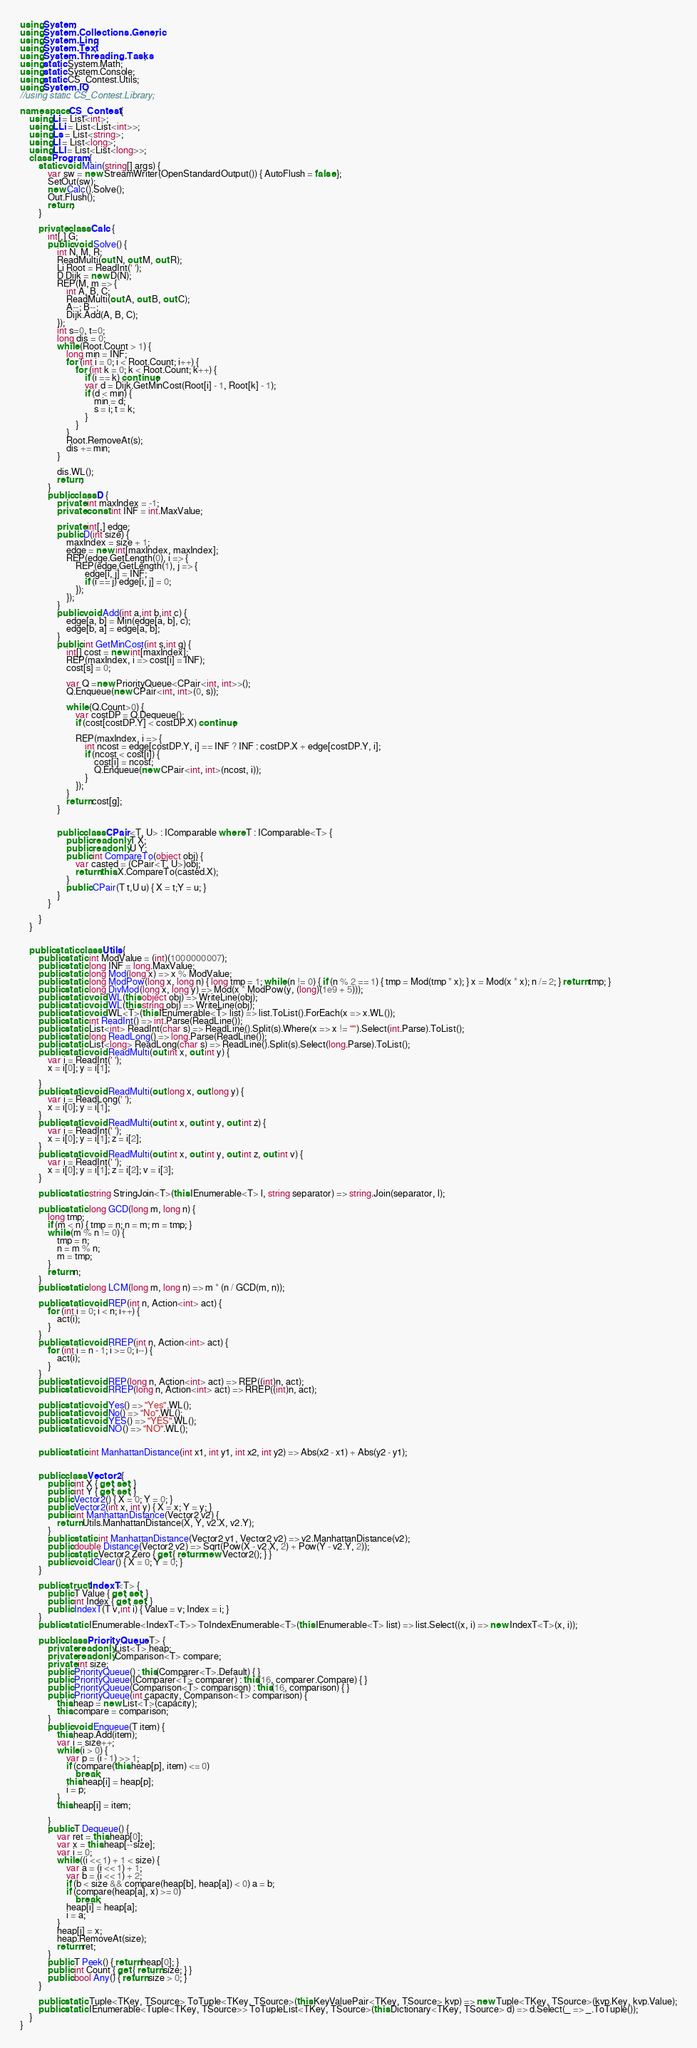Convert code to text. <code><loc_0><loc_0><loc_500><loc_500><_C#_>using System;
using System.Collections.Generic;
using System.Linq;
using System.Text;
using System.Threading.Tasks;
using static System.Math;
using static System.Console;
using static CS_Contest.Utils;
using System.IO;
//using static CS_Contest.Library;

namespace CS_Contest {
	using Li = List<int>;
	using LLi = List<List<int>>;
	using Ls = List<string>;
	using Ll = List<long>;
	using LLl = List<List<long>>;
	class Program {
		static void Main(string[] args) {
			var sw = new StreamWriter(OpenStandardOutput()) { AutoFlush = false };
			SetOut(sw);
			new Calc().Solve();
			Out.Flush();
			return;
        }

		private class Calc {
			int[,] G;
			public void Solve() {
				int N, M, R;
				ReadMulti(out N, out M, out R);
				Li Root = ReadInt(' ');
				D Dijk = new D(N);
				REP(M, m => {
					int A, B, C;
					ReadMulti(out A, out B, out C);
					A--; B--;
					Dijk.Add(A, B, C);
				});
				int s=0, t=0;
				long dis = 0;
				while (Root.Count > 1) {
					long min = INF;
					for (int i = 0; i < Root.Count; i++) {
						for (int k = 0; k < Root.Count; k++) {
							if (i == k) continue;
							var d = Dijk.GetMinCost(Root[i] - 1, Root[k] - 1);
							if (d < min) {
								min = d;
								s = i; t = k;
							}
						}
					}
					Root.RemoveAt(s);
					dis += min;
				}
				
				dis.WL();
				return;
			}
			public class D {
				private int maxIndex = -1;
				private const int INF = int.MaxValue;

				private int[,] edge;
				public D(int size) {
					maxIndex = size + 1;
					edge = new int[maxIndex, maxIndex];
					REP(edge.GetLength(0), i => {
						REP(edge.GetLength(1), j => {
							edge[i, j] = INF;
							if (i == j) edge[i, j] = 0;
						});
					});
				}
				public void Add(int a,int b,int c) {
					edge[a, b] = Min(edge[a, b], c);
					edge[b, a] = edge[a, b];
				}
				public int GetMinCost(int s,int g) {
					int[] cost = new int[maxIndex];
					REP(maxIndex, i => cost[i] = INF);
					cost[s] = 0;

					var Q =new PriorityQueue<CPair<int, int>>();
					Q.Enqueue(new CPair<int, int>(0, s));

					while (Q.Count>0) {
						var costDP = Q.Dequeue();
						if (cost[costDP.Y] < costDP.X) continue;

						REP(maxIndex, i => {
							int ncost = edge[costDP.Y, i] == INF ? INF : costDP.X + edge[costDP.Y, i];
							if (ncost < cost[i]) {
								cost[i] = ncost;
								Q.Enqueue(new CPair<int, int>(ncost, i));
							}
						});
					}
					return cost[g];
				}


				public class CPair<T, U> : IComparable where T : IComparable<T> {
					public readonly T X;
					public readonly U Y;
					public int CompareTo(object obj) {
						var casted = (CPair<T, U>)obj;
						return this.X.CompareTo(casted.X);
					}
					public CPair(T t,U u) { X = t;Y = u; }
				}
			}
			
		}
	}


	public static class Utils {
		public static int ModValue = (int)(1000000007);
		public static long INF = long.MaxValue;
		public static long Mod(long x) => x % ModValue;
		public static long ModPow(long x, long n) { long tmp = 1; while (n != 0) { if (n % 2 == 1) { tmp = Mod(tmp * x); } x = Mod(x * x); n /= 2; } return tmp; }
		public static long DivMod(long x, long y) => Mod(x * ModPow(y, (long)(1e9 + 5)));
		public static void WL(this object obj) => WriteLine(obj);
		public static void WL(this string obj) => WriteLine(obj);
		public static void WL<T>(this IEnumerable<T> list) => list.ToList().ForEach(x => x.WL());
		public static int ReadInt() => int.Parse(ReadLine());
		public static List<int> ReadInt(char s) => ReadLine().Split(s).Where(x => x != "").Select(int.Parse).ToList();
		public static long ReadLong() => long.Parse(ReadLine());
		public static List<long> ReadLong(char s) => ReadLine().Split(s).Select(long.Parse).ToList();
		public static void ReadMulti(out int x, out int y) {
			var i = ReadInt(' ');
			x = i[0]; y = i[1];

		}
		public static void ReadMulti(out long x, out long y) {
			var i = ReadLong(' ');
			x = i[0]; y = i[1];
		}
		public static void ReadMulti(out int x, out int y, out int z) {
			var i = ReadInt(' ');
			x = i[0]; y = i[1]; z = i[2];
		}
		public static void ReadMulti(out int x, out int y, out int z, out int v) {
			var i = ReadInt(' ');
			x = i[0]; y = i[1]; z = i[2]; v = i[3];
		}

		public static string StringJoin<T>(this IEnumerable<T> l, string separator) => string.Join(separator, l);

		public static long GCD(long m, long n) {
			long tmp;
			if (m < n) { tmp = n; n = m; m = tmp; }
			while (m % n != 0) {
				tmp = n;
				n = m % n;
				m = tmp;
			}
			return n;
		}
		public static long LCM(long m, long n) => m * (n / GCD(m, n));

		public static void REP(int n, Action<int> act) {
			for (int i = 0; i < n; i++) {
				act(i);
			}
		}
		public static void RREP(int n, Action<int> act) {
			for (int i = n - 1; i >= 0; i--) {
				act(i);
			}
		}
		public static void REP(long n, Action<int> act) => REP((int)n, act);
		public static void RREP(long n, Action<int> act) => RREP((int)n, act);

		public static void Yes() => "Yes".WL();
		public static void No() => "No".WL();
		public static void YES() => "YES".WL();
		public static void NO() => "NO".WL();


		public static int ManhattanDistance(int x1, int y1, int x2, int y2) => Abs(x2 - x1) + Abs(y2 - y1);


		public class Vector2 {
			public int X { get; set; }
			public int Y { get; set; }
			public Vector2() { X = 0; Y = 0; }
			public Vector2(int x, int y) { X = x; Y = y; }
			public int ManhattanDistance(Vector2 v2) {
				return Utils.ManhattanDistance(X, Y, v2.X, v2.Y);
			}
			public static int ManhattanDistance(Vector2 v1, Vector2 v2) => v2.ManhattanDistance(v2);
			public double Distance(Vector2 v2) => Sqrt(Pow(X - v2.X, 2) + Pow(Y - v2.Y, 2));
			public static Vector2 Zero { get { return new Vector2(); } }
			public void Clear() { X = 0; Y = 0; }
		}

		public struct IndexT<T> {
			public T Value { get; set; }
			public int Index { get; set; }
			public IndexT(T v,int i) { Value = v; Index = i; }
		}
		public static IEnumerable<IndexT<T>> ToIndexEnumerable<T>(this IEnumerable<T> list) => list.Select((x, i) => new IndexT<T>(x, i));

		public class PriorityQueue<T> {
			private readonly List<T> heap;
			private readonly Comparison<T> compare;
			private int size;
			public PriorityQueue() : this(Comparer<T>.Default) { }
			public PriorityQueue(IComparer<T> comparer) : this(16, comparer.Compare) { }
			public PriorityQueue(Comparison<T> comparison) : this(16, comparison) { }
			public PriorityQueue(int capacity, Comparison<T> comparison) {
				this.heap = new List<T>(capacity);
				this.compare = comparison;
			}
			public void Enqueue(T item) {
				this.heap.Add(item);
				var i = size++;
				while (i > 0) {
					var p = (i - 1) >> 1;
					if (compare(this.heap[p], item) <= 0)
						break;
					this.heap[i] = heap[p];
					i = p;
				}
				this.heap[i] = item;

			}
			public T Dequeue() {
				var ret = this.heap[0];
				var x = this.heap[--size];
				var i = 0;
				while ((i << 1) + 1 < size) {
					var a = (i << 1) + 1;
					var b = (i << 1) + 2;
					if (b < size && compare(heap[b], heap[a]) < 0) a = b;
					if (compare(heap[a], x) >= 0)
						break;
					heap[i] = heap[a];
					i = a;
				}
				heap[i] = x;
				heap.RemoveAt(size);
				return ret;
			}
			public T Peek() { return heap[0]; }
			public int Count { get { return size; } }
			public bool Any() { return size > 0; }
		}

		public static Tuple<TKey, TSource> ToTuple<TKey, TSource>(this KeyValuePair<TKey, TSource> kvp) => new Tuple<TKey, TSource>(kvp.Key, kvp.Value);
		public static IEnumerable<Tuple<TKey, TSource>> ToTupleList<TKey, TSource>(this Dictionary<TKey, TSource> d) => d.Select(_ => _.ToTuple());
	}
}
</code> 